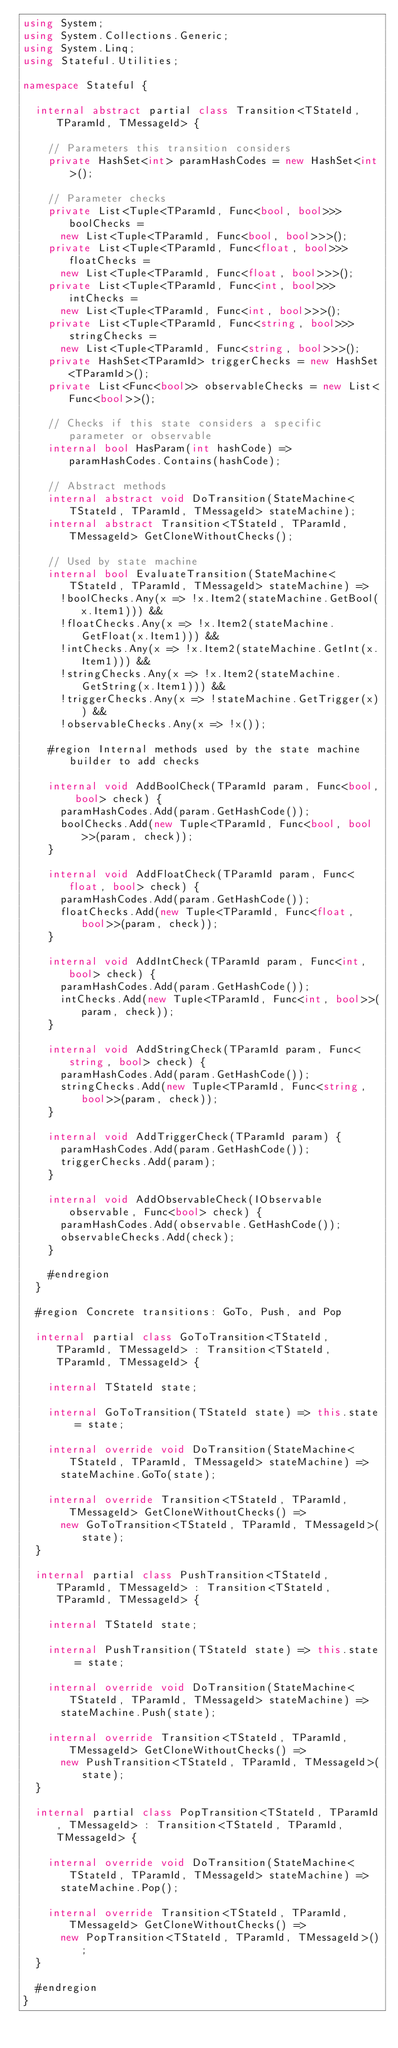<code> <loc_0><loc_0><loc_500><loc_500><_C#_>using System;
using System.Collections.Generic;
using System.Linq;
using Stateful.Utilities;

namespace Stateful {

	internal abstract partial class Transition<TStateId, TParamId, TMessageId> {

		// Parameters this transition considers
		private HashSet<int> paramHashCodes = new HashSet<int>();

		// Parameter checks
		private List<Tuple<TParamId, Func<bool, bool>>> boolChecks =
			new List<Tuple<TParamId, Func<bool, bool>>>();
		private List<Tuple<TParamId, Func<float, bool>>> floatChecks =
			new List<Tuple<TParamId, Func<float, bool>>>();
		private List<Tuple<TParamId, Func<int, bool>>> intChecks =
			new List<Tuple<TParamId, Func<int, bool>>>();
		private List<Tuple<TParamId, Func<string, bool>>> stringChecks =
			new List<Tuple<TParamId, Func<string, bool>>>();
		private HashSet<TParamId> triggerChecks = new HashSet<TParamId>();
		private List<Func<bool>> observableChecks = new List<Func<bool>>();

		// Checks if this state considers a specific parameter or observable
		internal bool HasParam(int hashCode) => paramHashCodes.Contains(hashCode);

		// Abstract methods
		internal abstract void DoTransition(StateMachine<TStateId, TParamId, TMessageId> stateMachine);
		internal abstract Transition<TStateId, TParamId, TMessageId> GetCloneWithoutChecks();

		// Used by state machine
		internal bool EvaluateTransition(StateMachine<TStateId, TParamId, TMessageId> stateMachine) =>
			!boolChecks.Any(x => !x.Item2(stateMachine.GetBool(x.Item1))) &&
			!floatChecks.Any(x => !x.Item2(stateMachine.GetFloat(x.Item1))) &&
			!intChecks.Any(x => !x.Item2(stateMachine.GetInt(x.Item1))) &&
			!stringChecks.Any(x => !x.Item2(stateMachine.GetString(x.Item1))) &&
			!triggerChecks.Any(x => !stateMachine.GetTrigger(x)) &&
			!observableChecks.Any(x => !x());

		#region Internal methods used by the state machine builder to add checks

		internal void AddBoolCheck(TParamId param, Func<bool, bool> check) {
			paramHashCodes.Add(param.GetHashCode());
			boolChecks.Add(new Tuple<TParamId, Func<bool, bool>>(param, check));
		}

		internal void AddFloatCheck(TParamId param, Func<float, bool> check) {
			paramHashCodes.Add(param.GetHashCode());
			floatChecks.Add(new Tuple<TParamId, Func<float, bool>>(param, check));
		}

		internal void AddIntCheck(TParamId param, Func<int, bool> check) {
			paramHashCodes.Add(param.GetHashCode());
			intChecks.Add(new Tuple<TParamId, Func<int, bool>>(param, check));
		}

		internal void AddStringCheck(TParamId param, Func<string, bool> check) {
			paramHashCodes.Add(param.GetHashCode());
			stringChecks.Add(new Tuple<TParamId, Func<string, bool>>(param, check));
		}

		internal void AddTriggerCheck(TParamId param) {
			paramHashCodes.Add(param.GetHashCode());
			triggerChecks.Add(param);
		}

		internal void AddObservableCheck(IObservable observable, Func<bool> check) {
			paramHashCodes.Add(observable.GetHashCode());
			observableChecks.Add(check);
		}

		#endregion
	}

	#region Concrete transitions: GoTo, Push, and Pop

	internal partial class GoToTransition<TStateId, TParamId, TMessageId> : Transition<TStateId, TParamId, TMessageId> {

		internal TStateId state;

		internal GoToTransition(TStateId state) => this.state = state;

		internal override void DoTransition(StateMachine<TStateId, TParamId, TMessageId> stateMachine) =>
			stateMachine.GoTo(state);

		internal override Transition<TStateId, TParamId, TMessageId> GetCloneWithoutChecks() =>
			new GoToTransition<TStateId, TParamId, TMessageId>(state);
	}

	internal partial class PushTransition<TStateId, TParamId, TMessageId> : Transition<TStateId, TParamId, TMessageId> {

		internal TStateId state;

		internal PushTransition(TStateId state) => this.state = state;

		internal override void DoTransition(StateMachine<TStateId, TParamId, TMessageId> stateMachine) =>
			stateMachine.Push(state);

		internal override Transition<TStateId, TParamId, TMessageId> GetCloneWithoutChecks() =>
			new PushTransition<TStateId, TParamId, TMessageId>(state);
	}

	internal partial class PopTransition<TStateId, TParamId, TMessageId> : Transition<TStateId, TParamId, TMessageId> {

		internal override void DoTransition(StateMachine<TStateId, TParamId, TMessageId> stateMachine) =>
			stateMachine.Pop();

		internal override Transition<TStateId, TParamId, TMessageId> GetCloneWithoutChecks() =>
			new PopTransition<TStateId, TParamId, TMessageId>();
	}

	#endregion
}
</code> 